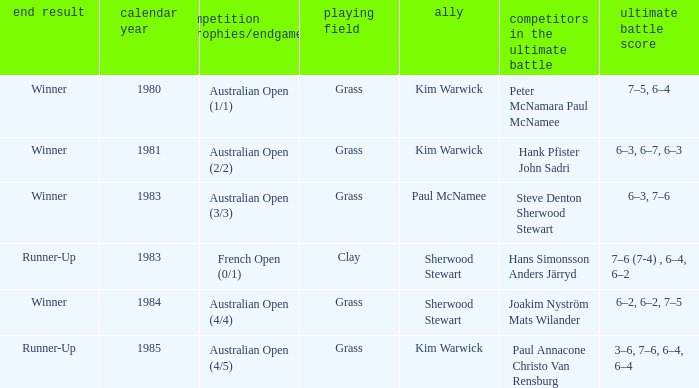How many different partners were played with during French Open (0/1)? 1.0. 